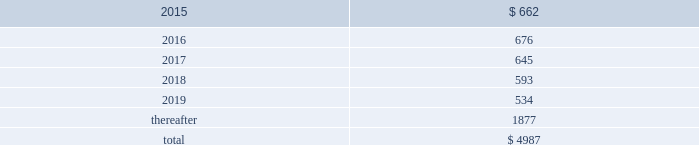Table of contents concentrations in the available sources of supply of materials and product although most components essential to the company 2019s business are generally available from multiple sources , a number of components are currently obtained from single or limited sources .
In addition , the company competes for various components with other participants in the markets for mobile communication and media devices and personal computers .
Therefore , many components used by the company , including those that are available from multiple sources , are at times subject to industry-wide shortage and significant pricing fluctuations that could materially adversely affect the company 2019s financial condition and operating results .
The company uses some custom components that are not commonly used by its competitors , and new products introduced by the company often utilize custom components available from only one source .
When a component or product uses new technologies , initial capacity constraints may exist until the suppliers 2019 yields have matured or manufacturing capacity has increased .
If the company 2019s supply of components for a new or existing product were delayed or constrained , or if an outsourcing partner delayed shipments of completed products to the company , the company 2019s financial condition and operating results could be materially adversely affected .
The company 2019s business and financial performance could also be materially adversely affected depending on the time required to obtain sufficient quantities from the original source , or to identify and obtain sufficient quantities from an alternative source .
Continued availability of these components at acceptable prices , or at all , may be affected if those suppliers concentrated on the production of common components instead of components customized to meet the company 2019s requirements .
The company has entered into agreements for the supply of many components ; however , there can be no guarantee that the company will be able to extend or renew these agreements on similar terms , or at all .
Therefore , the company remains subject to significant risks of supply shortages and price increases that could materially adversely affect its financial condition and operating results .
Substantially all of the company 2019s hardware products are manufactured by outsourcing partners that are located primarily in asia .
A significant concentration of this manufacturing is currently performed by a small number of outsourcing partners , often in single locations .
Certain of these outsourcing partners are the sole-sourced suppliers of components and manufacturers for many of the company 2019s products .
Although the company works closely with its outsourcing partners on manufacturing schedules , the company 2019s operating results could be adversely affected if its outsourcing partners were unable to meet their production commitments .
The company 2019s purchase commitments typically cover its requirements for periods up to 150 days .
Other off-balance sheet commitments operating leases the company leases various equipment and facilities , including retail space , under noncancelable operating lease arrangements .
The company does not currently utilize any other off-balance sheet financing arrangements .
The major facility leases are typically for terms not exceeding 10 years and generally contain multi-year renewal options .
Leases for retail space are for terms ranging from five to 20 years , the majority of which are for 10 years , and often contain multi-year renewal options .
As of september 27 , 2014 , the company 2019s total future minimum lease payments under noncancelable operating leases were $ 5.0 billion , of which $ 3.6 billion related to leases for retail space .
Rent expense under all operating leases , including both cancelable and noncancelable leases , was $ 717 million , $ 645 million and $ 488 million in 2014 , 2013 and 2012 , respectively .
Future minimum lease payments under noncancelable operating leases having remaining terms in excess of one year as of september 27 , 2014 , are as follows ( in millions ) : apple inc .
| 2014 form 10-k | 75 .

What percentage of future minimum lease payments under noncancelable operating leases are due after 2019? 
Computations: (1877 / 4987)
Answer: 0.37638. 